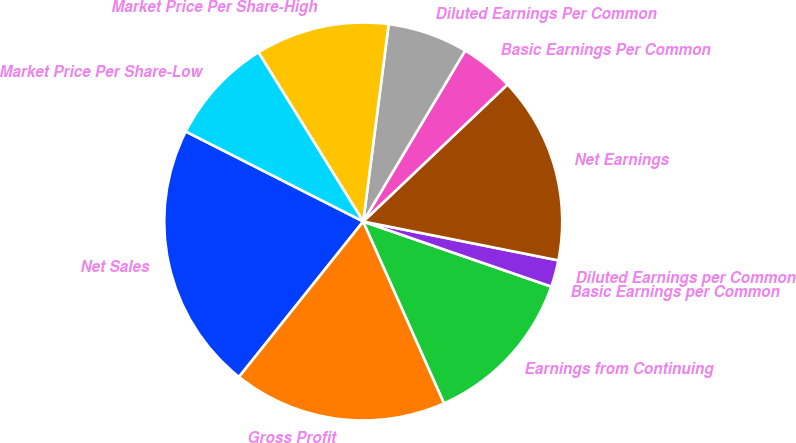Convert chart. <chart><loc_0><loc_0><loc_500><loc_500><pie_chart><fcel>Net Sales<fcel>Gross Profit<fcel>Earnings from Continuing<fcel>Basic Earnings per Common<fcel>Diluted Earnings per Common<fcel>Net Earnings<fcel>Basic Earnings Per Common<fcel>Diluted Earnings Per Common<fcel>Market Price Per Share-High<fcel>Market Price Per Share-Low<nl><fcel>21.74%<fcel>17.39%<fcel>13.04%<fcel>0.0%<fcel>2.17%<fcel>15.22%<fcel>4.35%<fcel>6.52%<fcel>10.87%<fcel>8.7%<nl></chart> 